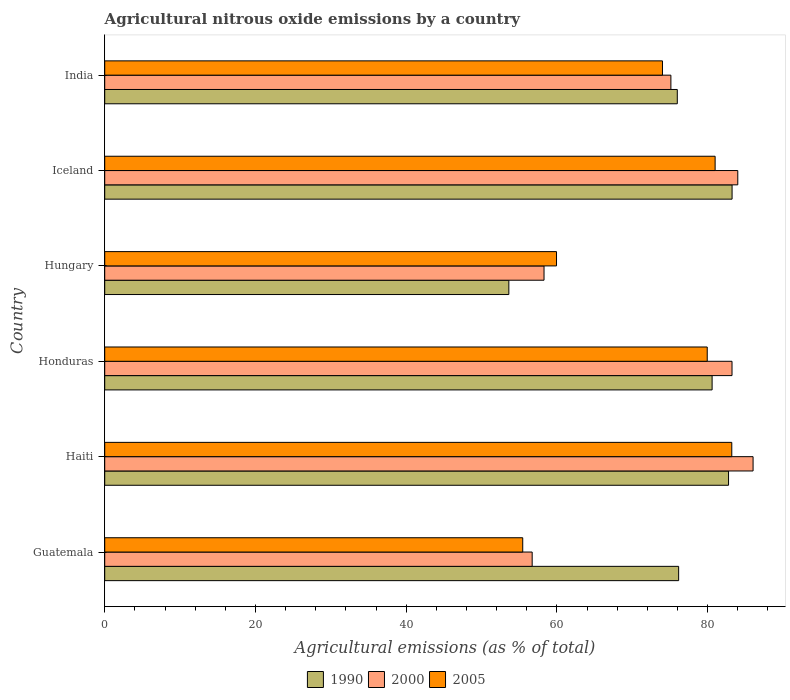How many different coloured bars are there?
Provide a succinct answer. 3. How many groups of bars are there?
Provide a short and direct response. 6. Are the number of bars per tick equal to the number of legend labels?
Give a very brief answer. Yes. Are the number of bars on each tick of the Y-axis equal?
Provide a short and direct response. Yes. How many bars are there on the 6th tick from the top?
Your answer should be compact. 3. What is the amount of agricultural nitrous oxide emitted in 2000 in Haiti?
Offer a terse response. 86.03. Across all countries, what is the maximum amount of agricultural nitrous oxide emitted in 2005?
Provide a short and direct response. 83.2. Across all countries, what is the minimum amount of agricultural nitrous oxide emitted in 1990?
Your answer should be very brief. 53.62. In which country was the amount of agricultural nitrous oxide emitted in 2000 minimum?
Your response must be concise. Guatemala. What is the total amount of agricultural nitrous oxide emitted in 1990 in the graph?
Give a very brief answer. 452.36. What is the difference between the amount of agricultural nitrous oxide emitted in 1990 in Iceland and that in India?
Provide a short and direct response. 7.27. What is the difference between the amount of agricultural nitrous oxide emitted in 1990 in Guatemala and the amount of agricultural nitrous oxide emitted in 2000 in Honduras?
Your response must be concise. -7.08. What is the average amount of agricultural nitrous oxide emitted in 1990 per country?
Make the answer very short. 75.39. What is the difference between the amount of agricultural nitrous oxide emitted in 2000 and amount of agricultural nitrous oxide emitted in 2005 in Honduras?
Make the answer very short. 3.29. In how many countries, is the amount of agricultural nitrous oxide emitted in 1990 greater than 68 %?
Make the answer very short. 5. What is the ratio of the amount of agricultural nitrous oxide emitted in 2005 in Guatemala to that in Haiti?
Your answer should be compact. 0.67. Is the difference between the amount of agricultural nitrous oxide emitted in 2000 in Honduras and India greater than the difference between the amount of agricultural nitrous oxide emitted in 2005 in Honduras and India?
Provide a short and direct response. Yes. What is the difference between the highest and the second highest amount of agricultural nitrous oxide emitted in 2005?
Give a very brief answer. 2.21. What is the difference between the highest and the lowest amount of agricultural nitrous oxide emitted in 2005?
Provide a succinct answer. 27.74. In how many countries, is the amount of agricultural nitrous oxide emitted in 2000 greater than the average amount of agricultural nitrous oxide emitted in 2000 taken over all countries?
Offer a terse response. 4. How many bars are there?
Your answer should be very brief. 18. How many countries are there in the graph?
Provide a short and direct response. 6. Are the values on the major ticks of X-axis written in scientific E-notation?
Your answer should be compact. No. Does the graph contain any zero values?
Offer a terse response. No. Does the graph contain grids?
Provide a short and direct response. No. Where does the legend appear in the graph?
Your answer should be compact. Bottom center. How are the legend labels stacked?
Make the answer very short. Horizontal. What is the title of the graph?
Provide a short and direct response. Agricultural nitrous oxide emissions by a country. Does "1968" appear as one of the legend labels in the graph?
Offer a terse response. No. What is the label or title of the X-axis?
Give a very brief answer. Agricultural emissions (as % of total). What is the label or title of the Y-axis?
Provide a short and direct response. Country. What is the Agricultural emissions (as % of total) of 1990 in Guatemala?
Give a very brief answer. 76.15. What is the Agricultural emissions (as % of total) in 2000 in Guatemala?
Offer a terse response. 56.72. What is the Agricultural emissions (as % of total) in 2005 in Guatemala?
Provide a short and direct response. 55.47. What is the Agricultural emissions (as % of total) in 1990 in Haiti?
Make the answer very short. 82.77. What is the Agricultural emissions (as % of total) of 2000 in Haiti?
Ensure brevity in your answer.  86.03. What is the Agricultural emissions (as % of total) in 2005 in Haiti?
Your answer should be compact. 83.2. What is the Agricultural emissions (as % of total) of 1990 in Honduras?
Ensure brevity in your answer.  80.59. What is the Agricultural emissions (as % of total) in 2000 in Honduras?
Your answer should be compact. 83.23. What is the Agricultural emissions (as % of total) of 2005 in Honduras?
Provide a succinct answer. 79.95. What is the Agricultural emissions (as % of total) of 1990 in Hungary?
Your answer should be very brief. 53.62. What is the Agricultural emissions (as % of total) in 2000 in Hungary?
Provide a succinct answer. 58.29. What is the Agricultural emissions (as % of total) in 2005 in Hungary?
Provide a succinct answer. 59.95. What is the Agricultural emissions (as % of total) in 1990 in Iceland?
Your response must be concise. 83.24. What is the Agricultural emissions (as % of total) of 2000 in Iceland?
Offer a very short reply. 84. What is the Agricultural emissions (as % of total) of 2005 in Iceland?
Make the answer very short. 80.99. What is the Agricultural emissions (as % of total) of 1990 in India?
Your answer should be compact. 75.97. What is the Agricultural emissions (as % of total) of 2000 in India?
Provide a succinct answer. 75.12. What is the Agricultural emissions (as % of total) of 2005 in India?
Your answer should be compact. 74.01. Across all countries, what is the maximum Agricultural emissions (as % of total) of 1990?
Keep it short and to the point. 83.24. Across all countries, what is the maximum Agricultural emissions (as % of total) in 2000?
Keep it short and to the point. 86.03. Across all countries, what is the maximum Agricultural emissions (as % of total) of 2005?
Ensure brevity in your answer.  83.2. Across all countries, what is the minimum Agricultural emissions (as % of total) of 1990?
Offer a very short reply. 53.62. Across all countries, what is the minimum Agricultural emissions (as % of total) in 2000?
Ensure brevity in your answer.  56.72. Across all countries, what is the minimum Agricultural emissions (as % of total) in 2005?
Offer a terse response. 55.47. What is the total Agricultural emissions (as % of total) of 1990 in the graph?
Your response must be concise. 452.36. What is the total Agricultural emissions (as % of total) in 2000 in the graph?
Make the answer very short. 443.4. What is the total Agricultural emissions (as % of total) in 2005 in the graph?
Ensure brevity in your answer.  433.56. What is the difference between the Agricultural emissions (as % of total) in 1990 in Guatemala and that in Haiti?
Offer a terse response. -6.62. What is the difference between the Agricultural emissions (as % of total) of 2000 in Guatemala and that in Haiti?
Provide a short and direct response. -29.31. What is the difference between the Agricultural emissions (as % of total) in 2005 in Guatemala and that in Haiti?
Give a very brief answer. -27.74. What is the difference between the Agricultural emissions (as % of total) of 1990 in Guatemala and that in Honduras?
Offer a very short reply. -4.44. What is the difference between the Agricultural emissions (as % of total) of 2000 in Guatemala and that in Honduras?
Make the answer very short. -26.52. What is the difference between the Agricultural emissions (as % of total) in 2005 in Guatemala and that in Honduras?
Offer a very short reply. -24.48. What is the difference between the Agricultural emissions (as % of total) of 1990 in Guatemala and that in Hungary?
Provide a short and direct response. 22.53. What is the difference between the Agricultural emissions (as % of total) of 2000 in Guatemala and that in Hungary?
Provide a succinct answer. -1.57. What is the difference between the Agricultural emissions (as % of total) of 2005 in Guatemala and that in Hungary?
Give a very brief answer. -4.48. What is the difference between the Agricultural emissions (as % of total) of 1990 in Guatemala and that in Iceland?
Keep it short and to the point. -7.09. What is the difference between the Agricultural emissions (as % of total) in 2000 in Guatemala and that in Iceland?
Keep it short and to the point. -27.28. What is the difference between the Agricultural emissions (as % of total) in 2005 in Guatemala and that in Iceland?
Your answer should be compact. -25.53. What is the difference between the Agricultural emissions (as % of total) in 1990 in Guatemala and that in India?
Ensure brevity in your answer.  0.18. What is the difference between the Agricultural emissions (as % of total) in 2000 in Guatemala and that in India?
Provide a succinct answer. -18.41. What is the difference between the Agricultural emissions (as % of total) in 2005 in Guatemala and that in India?
Keep it short and to the point. -18.54. What is the difference between the Agricultural emissions (as % of total) in 1990 in Haiti and that in Honduras?
Provide a succinct answer. 2.18. What is the difference between the Agricultural emissions (as % of total) of 2000 in Haiti and that in Honduras?
Provide a short and direct response. 2.79. What is the difference between the Agricultural emissions (as % of total) of 2005 in Haiti and that in Honduras?
Keep it short and to the point. 3.26. What is the difference between the Agricultural emissions (as % of total) in 1990 in Haiti and that in Hungary?
Offer a very short reply. 29.15. What is the difference between the Agricultural emissions (as % of total) in 2000 in Haiti and that in Hungary?
Make the answer very short. 27.74. What is the difference between the Agricultural emissions (as % of total) in 2005 in Haiti and that in Hungary?
Your answer should be very brief. 23.25. What is the difference between the Agricultural emissions (as % of total) of 1990 in Haiti and that in Iceland?
Offer a very short reply. -0.47. What is the difference between the Agricultural emissions (as % of total) of 2000 in Haiti and that in Iceland?
Give a very brief answer. 2.03. What is the difference between the Agricultural emissions (as % of total) in 2005 in Haiti and that in Iceland?
Give a very brief answer. 2.21. What is the difference between the Agricultural emissions (as % of total) of 1990 in Haiti and that in India?
Provide a succinct answer. 6.8. What is the difference between the Agricultural emissions (as % of total) in 2000 in Haiti and that in India?
Your answer should be compact. 10.9. What is the difference between the Agricultural emissions (as % of total) in 2005 in Haiti and that in India?
Your answer should be very brief. 9.2. What is the difference between the Agricultural emissions (as % of total) of 1990 in Honduras and that in Hungary?
Provide a short and direct response. 26.97. What is the difference between the Agricultural emissions (as % of total) in 2000 in Honduras and that in Hungary?
Provide a succinct answer. 24.94. What is the difference between the Agricultural emissions (as % of total) of 2005 in Honduras and that in Hungary?
Keep it short and to the point. 20. What is the difference between the Agricultural emissions (as % of total) of 1990 in Honduras and that in Iceland?
Offer a very short reply. -2.65. What is the difference between the Agricultural emissions (as % of total) of 2000 in Honduras and that in Iceland?
Give a very brief answer. -0.77. What is the difference between the Agricultural emissions (as % of total) of 2005 in Honduras and that in Iceland?
Offer a terse response. -1.05. What is the difference between the Agricultural emissions (as % of total) in 1990 in Honduras and that in India?
Your response must be concise. 4.62. What is the difference between the Agricultural emissions (as % of total) of 2000 in Honduras and that in India?
Ensure brevity in your answer.  8.11. What is the difference between the Agricultural emissions (as % of total) of 2005 in Honduras and that in India?
Provide a short and direct response. 5.94. What is the difference between the Agricultural emissions (as % of total) of 1990 in Hungary and that in Iceland?
Your answer should be very brief. -29.62. What is the difference between the Agricultural emissions (as % of total) in 2000 in Hungary and that in Iceland?
Ensure brevity in your answer.  -25.71. What is the difference between the Agricultural emissions (as % of total) of 2005 in Hungary and that in Iceland?
Keep it short and to the point. -21.04. What is the difference between the Agricultural emissions (as % of total) in 1990 in Hungary and that in India?
Your answer should be compact. -22.35. What is the difference between the Agricultural emissions (as % of total) of 2000 in Hungary and that in India?
Your response must be concise. -16.83. What is the difference between the Agricultural emissions (as % of total) in 2005 in Hungary and that in India?
Your response must be concise. -14.06. What is the difference between the Agricultural emissions (as % of total) of 1990 in Iceland and that in India?
Offer a very short reply. 7.27. What is the difference between the Agricultural emissions (as % of total) in 2000 in Iceland and that in India?
Make the answer very short. 8.88. What is the difference between the Agricultural emissions (as % of total) of 2005 in Iceland and that in India?
Make the answer very short. 6.99. What is the difference between the Agricultural emissions (as % of total) of 1990 in Guatemala and the Agricultural emissions (as % of total) of 2000 in Haiti?
Offer a very short reply. -9.88. What is the difference between the Agricultural emissions (as % of total) of 1990 in Guatemala and the Agricultural emissions (as % of total) of 2005 in Haiti?
Provide a short and direct response. -7.05. What is the difference between the Agricultural emissions (as % of total) of 2000 in Guatemala and the Agricultural emissions (as % of total) of 2005 in Haiti?
Keep it short and to the point. -26.48. What is the difference between the Agricultural emissions (as % of total) in 1990 in Guatemala and the Agricultural emissions (as % of total) in 2000 in Honduras?
Keep it short and to the point. -7.08. What is the difference between the Agricultural emissions (as % of total) in 1990 in Guatemala and the Agricultural emissions (as % of total) in 2005 in Honduras?
Your answer should be very brief. -3.79. What is the difference between the Agricultural emissions (as % of total) of 2000 in Guatemala and the Agricultural emissions (as % of total) of 2005 in Honduras?
Ensure brevity in your answer.  -23.23. What is the difference between the Agricultural emissions (as % of total) of 1990 in Guatemala and the Agricultural emissions (as % of total) of 2000 in Hungary?
Give a very brief answer. 17.86. What is the difference between the Agricultural emissions (as % of total) of 1990 in Guatemala and the Agricultural emissions (as % of total) of 2005 in Hungary?
Keep it short and to the point. 16.2. What is the difference between the Agricultural emissions (as % of total) in 2000 in Guatemala and the Agricultural emissions (as % of total) in 2005 in Hungary?
Offer a terse response. -3.23. What is the difference between the Agricultural emissions (as % of total) in 1990 in Guatemala and the Agricultural emissions (as % of total) in 2000 in Iceland?
Offer a terse response. -7.85. What is the difference between the Agricultural emissions (as % of total) in 1990 in Guatemala and the Agricultural emissions (as % of total) in 2005 in Iceland?
Offer a very short reply. -4.84. What is the difference between the Agricultural emissions (as % of total) in 2000 in Guatemala and the Agricultural emissions (as % of total) in 2005 in Iceland?
Offer a very short reply. -24.27. What is the difference between the Agricultural emissions (as % of total) of 1990 in Guatemala and the Agricultural emissions (as % of total) of 2000 in India?
Give a very brief answer. 1.03. What is the difference between the Agricultural emissions (as % of total) of 1990 in Guatemala and the Agricultural emissions (as % of total) of 2005 in India?
Make the answer very short. 2.15. What is the difference between the Agricultural emissions (as % of total) in 2000 in Guatemala and the Agricultural emissions (as % of total) in 2005 in India?
Ensure brevity in your answer.  -17.29. What is the difference between the Agricultural emissions (as % of total) in 1990 in Haiti and the Agricultural emissions (as % of total) in 2000 in Honduras?
Your response must be concise. -0.46. What is the difference between the Agricultural emissions (as % of total) in 1990 in Haiti and the Agricultural emissions (as % of total) in 2005 in Honduras?
Provide a short and direct response. 2.83. What is the difference between the Agricultural emissions (as % of total) in 2000 in Haiti and the Agricultural emissions (as % of total) in 2005 in Honduras?
Provide a short and direct response. 6.08. What is the difference between the Agricultural emissions (as % of total) in 1990 in Haiti and the Agricultural emissions (as % of total) in 2000 in Hungary?
Your answer should be compact. 24.48. What is the difference between the Agricultural emissions (as % of total) of 1990 in Haiti and the Agricultural emissions (as % of total) of 2005 in Hungary?
Your answer should be compact. 22.83. What is the difference between the Agricultural emissions (as % of total) in 2000 in Haiti and the Agricultural emissions (as % of total) in 2005 in Hungary?
Make the answer very short. 26.08. What is the difference between the Agricultural emissions (as % of total) in 1990 in Haiti and the Agricultural emissions (as % of total) in 2000 in Iceland?
Provide a short and direct response. -1.23. What is the difference between the Agricultural emissions (as % of total) of 1990 in Haiti and the Agricultural emissions (as % of total) of 2005 in Iceland?
Give a very brief answer. 1.78. What is the difference between the Agricultural emissions (as % of total) of 2000 in Haiti and the Agricultural emissions (as % of total) of 2005 in Iceland?
Your response must be concise. 5.04. What is the difference between the Agricultural emissions (as % of total) of 1990 in Haiti and the Agricultural emissions (as % of total) of 2000 in India?
Give a very brief answer. 7.65. What is the difference between the Agricultural emissions (as % of total) of 1990 in Haiti and the Agricultural emissions (as % of total) of 2005 in India?
Your answer should be compact. 8.77. What is the difference between the Agricultural emissions (as % of total) of 2000 in Haiti and the Agricultural emissions (as % of total) of 2005 in India?
Your response must be concise. 12.02. What is the difference between the Agricultural emissions (as % of total) in 1990 in Honduras and the Agricultural emissions (as % of total) in 2000 in Hungary?
Make the answer very short. 22.3. What is the difference between the Agricultural emissions (as % of total) in 1990 in Honduras and the Agricultural emissions (as % of total) in 2005 in Hungary?
Provide a succinct answer. 20.64. What is the difference between the Agricultural emissions (as % of total) of 2000 in Honduras and the Agricultural emissions (as % of total) of 2005 in Hungary?
Your answer should be compact. 23.29. What is the difference between the Agricultural emissions (as % of total) of 1990 in Honduras and the Agricultural emissions (as % of total) of 2000 in Iceland?
Your answer should be very brief. -3.41. What is the difference between the Agricultural emissions (as % of total) of 1990 in Honduras and the Agricultural emissions (as % of total) of 2005 in Iceland?
Make the answer very short. -0.4. What is the difference between the Agricultural emissions (as % of total) of 2000 in Honduras and the Agricultural emissions (as % of total) of 2005 in Iceland?
Your response must be concise. 2.24. What is the difference between the Agricultural emissions (as % of total) of 1990 in Honduras and the Agricultural emissions (as % of total) of 2000 in India?
Give a very brief answer. 5.47. What is the difference between the Agricultural emissions (as % of total) of 1990 in Honduras and the Agricultural emissions (as % of total) of 2005 in India?
Offer a terse response. 6.59. What is the difference between the Agricultural emissions (as % of total) of 2000 in Honduras and the Agricultural emissions (as % of total) of 2005 in India?
Your answer should be compact. 9.23. What is the difference between the Agricultural emissions (as % of total) of 1990 in Hungary and the Agricultural emissions (as % of total) of 2000 in Iceland?
Keep it short and to the point. -30.38. What is the difference between the Agricultural emissions (as % of total) in 1990 in Hungary and the Agricultural emissions (as % of total) in 2005 in Iceland?
Your answer should be very brief. -27.37. What is the difference between the Agricultural emissions (as % of total) of 2000 in Hungary and the Agricultural emissions (as % of total) of 2005 in Iceland?
Your response must be concise. -22.7. What is the difference between the Agricultural emissions (as % of total) in 1990 in Hungary and the Agricultural emissions (as % of total) in 2000 in India?
Your answer should be compact. -21.5. What is the difference between the Agricultural emissions (as % of total) in 1990 in Hungary and the Agricultural emissions (as % of total) in 2005 in India?
Provide a succinct answer. -20.38. What is the difference between the Agricultural emissions (as % of total) in 2000 in Hungary and the Agricultural emissions (as % of total) in 2005 in India?
Give a very brief answer. -15.72. What is the difference between the Agricultural emissions (as % of total) of 1990 in Iceland and the Agricultural emissions (as % of total) of 2000 in India?
Your answer should be very brief. 8.12. What is the difference between the Agricultural emissions (as % of total) in 1990 in Iceland and the Agricultural emissions (as % of total) in 2005 in India?
Your response must be concise. 9.24. What is the difference between the Agricultural emissions (as % of total) of 2000 in Iceland and the Agricultural emissions (as % of total) of 2005 in India?
Offer a very short reply. 9.99. What is the average Agricultural emissions (as % of total) of 1990 per country?
Your answer should be very brief. 75.39. What is the average Agricultural emissions (as % of total) of 2000 per country?
Your response must be concise. 73.9. What is the average Agricultural emissions (as % of total) of 2005 per country?
Your response must be concise. 72.26. What is the difference between the Agricultural emissions (as % of total) in 1990 and Agricultural emissions (as % of total) in 2000 in Guatemala?
Give a very brief answer. 19.43. What is the difference between the Agricultural emissions (as % of total) of 1990 and Agricultural emissions (as % of total) of 2005 in Guatemala?
Offer a terse response. 20.69. What is the difference between the Agricultural emissions (as % of total) of 2000 and Agricultural emissions (as % of total) of 2005 in Guatemala?
Ensure brevity in your answer.  1.25. What is the difference between the Agricultural emissions (as % of total) of 1990 and Agricultural emissions (as % of total) of 2000 in Haiti?
Offer a very short reply. -3.25. What is the difference between the Agricultural emissions (as % of total) in 1990 and Agricultural emissions (as % of total) in 2005 in Haiti?
Provide a succinct answer. -0.43. What is the difference between the Agricultural emissions (as % of total) in 2000 and Agricultural emissions (as % of total) in 2005 in Haiti?
Provide a short and direct response. 2.83. What is the difference between the Agricultural emissions (as % of total) of 1990 and Agricultural emissions (as % of total) of 2000 in Honduras?
Provide a succinct answer. -2.64. What is the difference between the Agricultural emissions (as % of total) of 1990 and Agricultural emissions (as % of total) of 2005 in Honduras?
Make the answer very short. 0.65. What is the difference between the Agricultural emissions (as % of total) in 2000 and Agricultural emissions (as % of total) in 2005 in Honduras?
Offer a terse response. 3.29. What is the difference between the Agricultural emissions (as % of total) in 1990 and Agricultural emissions (as % of total) in 2000 in Hungary?
Provide a short and direct response. -4.67. What is the difference between the Agricultural emissions (as % of total) of 1990 and Agricultural emissions (as % of total) of 2005 in Hungary?
Provide a short and direct response. -6.33. What is the difference between the Agricultural emissions (as % of total) in 2000 and Agricultural emissions (as % of total) in 2005 in Hungary?
Provide a succinct answer. -1.66. What is the difference between the Agricultural emissions (as % of total) of 1990 and Agricultural emissions (as % of total) of 2000 in Iceland?
Your answer should be compact. -0.76. What is the difference between the Agricultural emissions (as % of total) in 1990 and Agricultural emissions (as % of total) in 2005 in Iceland?
Ensure brevity in your answer.  2.25. What is the difference between the Agricultural emissions (as % of total) in 2000 and Agricultural emissions (as % of total) in 2005 in Iceland?
Your response must be concise. 3.01. What is the difference between the Agricultural emissions (as % of total) in 1990 and Agricultural emissions (as % of total) in 2000 in India?
Give a very brief answer. 0.85. What is the difference between the Agricultural emissions (as % of total) of 1990 and Agricultural emissions (as % of total) of 2005 in India?
Ensure brevity in your answer.  1.97. What is the difference between the Agricultural emissions (as % of total) in 2000 and Agricultural emissions (as % of total) in 2005 in India?
Your answer should be very brief. 1.12. What is the ratio of the Agricultural emissions (as % of total) of 1990 in Guatemala to that in Haiti?
Make the answer very short. 0.92. What is the ratio of the Agricultural emissions (as % of total) of 2000 in Guatemala to that in Haiti?
Offer a terse response. 0.66. What is the ratio of the Agricultural emissions (as % of total) of 2005 in Guatemala to that in Haiti?
Offer a very short reply. 0.67. What is the ratio of the Agricultural emissions (as % of total) in 1990 in Guatemala to that in Honduras?
Make the answer very short. 0.94. What is the ratio of the Agricultural emissions (as % of total) in 2000 in Guatemala to that in Honduras?
Your answer should be compact. 0.68. What is the ratio of the Agricultural emissions (as % of total) in 2005 in Guatemala to that in Honduras?
Your answer should be compact. 0.69. What is the ratio of the Agricultural emissions (as % of total) of 1990 in Guatemala to that in Hungary?
Give a very brief answer. 1.42. What is the ratio of the Agricultural emissions (as % of total) in 2005 in Guatemala to that in Hungary?
Provide a short and direct response. 0.93. What is the ratio of the Agricultural emissions (as % of total) of 1990 in Guatemala to that in Iceland?
Your answer should be very brief. 0.91. What is the ratio of the Agricultural emissions (as % of total) of 2000 in Guatemala to that in Iceland?
Provide a short and direct response. 0.68. What is the ratio of the Agricultural emissions (as % of total) of 2005 in Guatemala to that in Iceland?
Your answer should be very brief. 0.68. What is the ratio of the Agricultural emissions (as % of total) in 2000 in Guatemala to that in India?
Offer a terse response. 0.76. What is the ratio of the Agricultural emissions (as % of total) of 2005 in Guatemala to that in India?
Make the answer very short. 0.75. What is the ratio of the Agricultural emissions (as % of total) of 1990 in Haiti to that in Honduras?
Offer a very short reply. 1.03. What is the ratio of the Agricultural emissions (as % of total) in 2000 in Haiti to that in Honduras?
Your answer should be compact. 1.03. What is the ratio of the Agricultural emissions (as % of total) in 2005 in Haiti to that in Honduras?
Keep it short and to the point. 1.04. What is the ratio of the Agricultural emissions (as % of total) in 1990 in Haiti to that in Hungary?
Make the answer very short. 1.54. What is the ratio of the Agricultural emissions (as % of total) of 2000 in Haiti to that in Hungary?
Give a very brief answer. 1.48. What is the ratio of the Agricultural emissions (as % of total) of 2005 in Haiti to that in Hungary?
Give a very brief answer. 1.39. What is the ratio of the Agricultural emissions (as % of total) in 2000 in Haiti to that in Iceland?
Offer a very short reply. 1.02. What is the ratio of the Agricultural emissions (as % of total) of 2005 in Haiti to that in Iceland?
Your response must be concise. 1.03. What is the ratio of the Agricultural emissions (as % of total) in 1990 in Haiti to that in India?
Ensure brevity in your answer.  1.09. What is the ratio of the Agricultural emissions (as % of total) in 2000 in Haiti to that in India?
Your response must be concise. 1.15. What is the ratio of the Agricultural emissions (as % of total) of 2005 in Haiti to that in India?
Give a very brief answer. 1.12. What is the ratio of the Agricultural emissions (as % of total) of 1990 in Honduras to that in Hungary?
Ensure brevity in your answer.  1.5. What is the ratio of the Agricultural emissions (as % of total) in 2000 in Honduras to that in Hungary?
Offer a terse response. 1.43. What is the ratio of the Agricultural emissions (as % of total) of 2005 in Honduras to that in Hungary?
Your answer should be compact. 1.33. What is the ratio of the Agricultural emissions (as % of total) in 1990 in Honduras to that in Iceland?
Offer a very short reply. 0.97. What is the ratio of the Agricultural emissions (as % of total) of 2000 in Honduras to that in Iceland?
Give a very brief answer. 0.99. What is the ratio of the Agricultural emissions (as % of total) in 2005 in Honduras to that in Iceland?
Provide a short and direct response. 0.99. What is the ratio of the Agricultural emissions (as % of total) of 1990 in Honduras to that in India?
Your answer should be very brief. 1.06. What is the ratio of the Agricultural emissions (as % of total) of 2000 in Honduras to that in India?
Your response must be concise. 1.11. What is the ratio of the Agricultural emissions (as % of total) in 2005 in Honduras to that in India?
Your answer should be very brief. 1.08. What is the ratio of the Agricultural emissions (as % of total) in 1990 in Hungary to that in Iceland?
Provide a short and direct response. 0.64. What is the ratio of the Agricultural emissions (as % of total) of 2000 in Hungary to that in Iceland?
Make the answer very short. 0.69. What is the ratio of the Agricultural emissions (as % of total) of 2005 in Hungary to that in Iceland?
Make the answer very short. 0.74. What is the ratio of the Agricultural emissions (as % of total) in 1990 in Hungary to that in India?
Your answer should be very brief. 0.71. What is the ratio of the Agricultural emissions (as % of total) of 2000 in Hungary to that in India?
Your response must be concise. 0.78. What is the ratio of the Agricultural emissions (as % of total) in 2005 in Hungary to that in India?
Make the answer very short. 0.81. What is the ratio of the Agricultural emissions (as % of total) of 1990 in Iceland to that in India?
Your response must be concise. 1.1. What is the ratio of the Agricultural emissions (as % of total) of 2000 in Iceland to that in India?
Your answer should be very brief. 1.12. What is the ratio of the Agricultural emissions (as % of total) of 2005 in Iceland to that in India?
Ensure brevity in your answer.  1.09. What is the difference between the highest and the second highest Agricultural emissions (as % of total) in 1990?
Offer a terse response. 0.47. What is the difference between the highest and the second highest Agricultural emissions (as % of total) in 2000?
Keep it short and to the point. 2.03. What is the difference between the highest and the second highest Agricultural emissions (as % of total) of 2005?
Provide a succinct answer. 2.21. What is the difference between the highest and the lowest Agricultural emissions (as % of total) in 1990?
Offer a terse response. 29.62. What is the difference between the highest and the lowest Agricultural emissions (as % of total) of 2000?
Ensure brevity in your answer.  29.31. What is the difference between the highest and the lowest Agricultural emissions (as % of total) in 2005?
Keep it short and to the point. 27.74. 